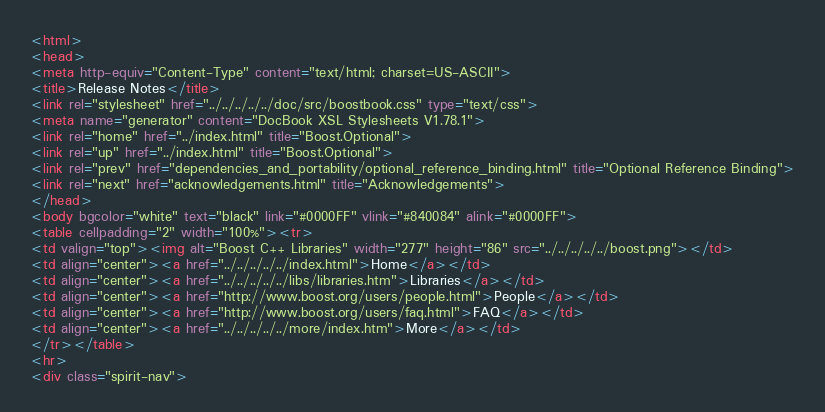Convert code to text. <code><loc_0><loc_0><loc_500><loc_500><_HTML_><html>
<head>
<meta http-equiv="Content-Type" content="text/html; charset=US-ASCII">
<title>Release Notes</title>
<link rel="stylesheet" href="../../../../../doc/src/boostbook.css" type="text/css">
<meta name="generator" content="DocBook XSL Stylesheets V1.78.1">
<link rel="home" href="../index.html" title="Boost.Optional">
<link rel="up" href="../index.html" title="Boost.Optional">
<link rel="prev" href="dependencies_and_portability/optional_reference_binding.html" title="Optional Reference Binding">
<link rel="next" href="acknowledgements.html" title="Acknowledgements">
</head>
<body bgcolor="white" text="black" link="#0000FF" vlink="#840084" alink="#0000FF">
<table cellpadding="2" width="100%"><tr>
<td valign="top"><img alt="Boost C++ Libraries" width="277" height="86" src="../../../../../boost.png"></td>
<td align="center"><a href="../../../../../index.html">Home</a></td>
<td align="center"><a href="../../../../../libs/libraries.htm">Libraries</a></td>
<td align="center"><a href="http://www.boost.org/users/people.html">People</a></td>
<td align="center"><a href="http://www.boost.org/users/faq.html">FAQ</a></td>
<td align="center"><a href="../../../../../more/index.htm">More</a></td>
</tr></table>
<hr>
<div class="spirit-nav"></code> 